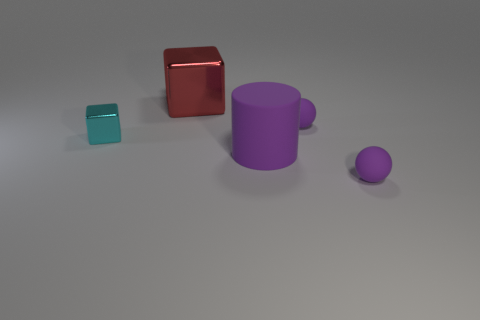Are there the same number of red objects that are in front of the purple matte cylinder and small rubber balls that are in front of the small cyan object?
Your answer should be very brief. No. How many other big cubes are the same color as the large shiny cube?
Give a very brief answer. 0. What number of matte things are small cubes or big blue cubes?
Make the answer very short. 0. Is the shape of the small purple object that is behind the purple rubber cylinder the same as the tiny thing in front of the cyan metallic cube?
Provide a short and direct response. Yes. There is a big red block; how many cyan blocks are in front of it?
Your response must be concise. 1. Are there any other objects made of the same material as the tiny cyan object?
Offer a very short reply. Yes. There is a thing that is the same size as the purple matte cylinder; what is it made of?
Make the answer very short. Metal. Is the material of the big cylinder the same as the tiny cyan thing?
Your answer should be compact. No. How many things are either red metallic blocks or rubber balls?
Provide a short and direct response. 3. There is a big thing that is behind the big purple cylinder; what is its shape?
Your answer should be very brief. Cube. 